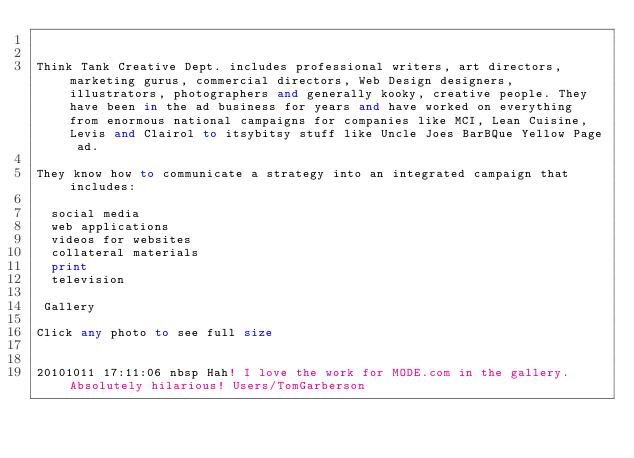Convert code to text. <code><loc_0><loc_0><loc_500><loc_500><_FORTRAN_>

Think Tank Creative Dept. includes professional writers, art directors, marketing gurus, commercial directors, Web Design designers, illustrators, photographers and generally kooky, creative people. They have been in the ad business for years and have worked on everything from enormous national campaigns for companies like MCI, Lean Cuisine, Levis and Clairol to itsybitsy stuff like Uncle Joes BarBQue Yellow Page ad.

They know how to communicate a strategy into an integrated campaign that includes:

  social media
  web applications
  videos for websites
  collateral materials
  print
  television

 Gallery 

Click any photo to see full size


20101011 17:11:06 nbsp Hah! I love the work for MODE.com in the gallery.  Absolutely hilarious! Users/TomGarberson
</code> 